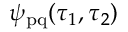Convert formula to latex. <formula><loc_0><loc_0><loc_500><loc_500>\psi _ { p q } ( \tau _ { 1 } , \tau _ { 2 } )</formula> 